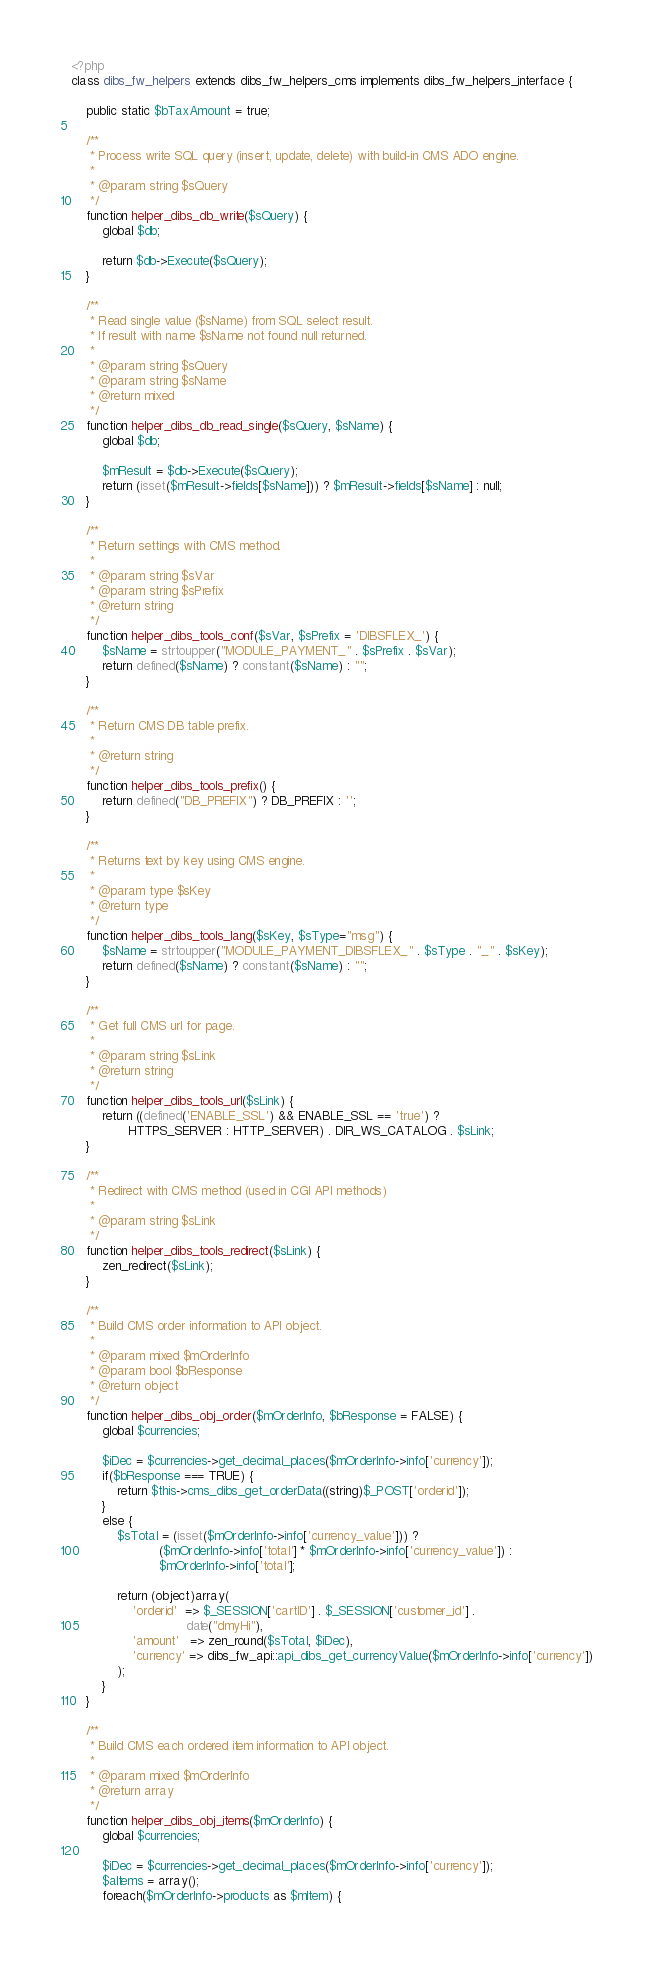<code> <loc_0><loc_0><loc_500><loc_500><_PHP_><?php
class dibs_fw_helpers extends dibs_fw_helpers_cms implements dibs_fw_helpers_interface {

    public static $bTaxAmount = true;
    
    /**
     * Process write SQL query (insert, update, delete) with build-in CMS ADO engine.
     * 
     * @param string $sQuery 
     */
    function helper_dibs_db_write($sQuery) {
        global $db;

        return $db->Execute($sQuery);
    }
    
    /**
     * Read single value ($sName) from SQL select result.
     * If result with name $sName not found null returned.
     * 
     * @param string $sQuery
     * @param string $sName
     * @return mixed 
     */
    function helper_dibs_db_read_single($sQuery, $sName) {
        global $db;
        
        $mResult = $db->Execute($sQuery);
        return (isset($mResult->fields[$sName])) ? $mResult->fields[$sName] : null;
    }
    
    /**
     * Return settings with CMS method.
     * 
     * @param string $sVar
     * @param string $sPrefix
     * @return string 
     */
    function helper_dibs_tools_conf($sVar, $sPrefix = 'DIBSFLEX_') {
        $sName = strtoupper("MODULE_PAYMENT_" . $sPrefix . $sVar);
        return defined($sName) ? constant($sName) : "";
    }
    
    /**
     * Return CMS DB table prefix.
     * 
     * @return string 
     */
    function helper_dibs_tools_prefix() {
        return defined("DB_PREFIX") ? DB_PREFIX : '';
    }
    
    /**
     * Returns text by key using CMS engine.
     * 
     * @param type $sKey
     * @return type 
     */
    function helper_dibs_tools_lang($sKey, $sType="msg") {
        $sName = strtoupper("MODULE_PAYMENT_DIBSFLEX_" . $sType . "_" . $sKey);
        return defined($sName) ? constant($sName) : "";
    }

    /**
     * Get full CMS url for page.
     * 
     * @param string $sLink
     * @return string 
     */
    function helper_dibs_tools_url($sLink) {
        return ((defined('ENABLE_SSL') && ENABLE_SSL == 'true') ? 
               HTTPS_SERVER : HTTP_SERVER) . DIR_WS_CATALOG . $sLink;
    }

    /**
     * Redirect with CMS method (used in CGI API methods)
     * 
     * @param string $sLink 
     */
    function helper_dibs_tools_redirect($sLink) {
        zen_redirect($sLink);
    }
    
    /**
     * Build CMS order information to API object.
     * 
     * @param mixed $mOrderInfo
     * @param bool $bResponse
     * @return object 
     */
    function helper_dibs_obj_order($mOrderInfo, $bResponse = FALSE) {
        global $currencies;
        
        $iDec = $currencies->get_decimal_places($mOrderInfo->info['currency']);
        if($bResponse === TRUE) {
            return $this->cms_dibs_get_orderData((string)$_POST['orderid']);
        }
        else {
            $sTotal = (isset($mOrderInfo->info['currency_value'])) ? 
                       ($mOrderInfo->info['total'] * $mOrderInfo->info['currency_value']) :
                       $mOrderInfo->info['total'];
            
            return (object)array(
                'orderid'  => $_SESSION['cartID'] . $_SESSION['customer_id'] . 
                              date("dmyHi"),
                'amount'   => zen_round($sTotal, $iDec),
                'currency' => dibs_fw_api::api_dibs_get_currencyValue($mOrderInfo->info['currency'])
            );
        }
    }
    
    /**
     * Build CMS each ordered item information to API object.
     * 
     * @param mixed $mOrderInfo
     * @return array 
     */
    function helper_dibs_obj_items($mOrderInfo) {
        global $currencies;
        
        $iDec = $currencies->get_decimal_places($mOrderInfo->info['currency']);
        $aItems = array();
        foreach($mOrderInfo->products as $mItem) {</code> 